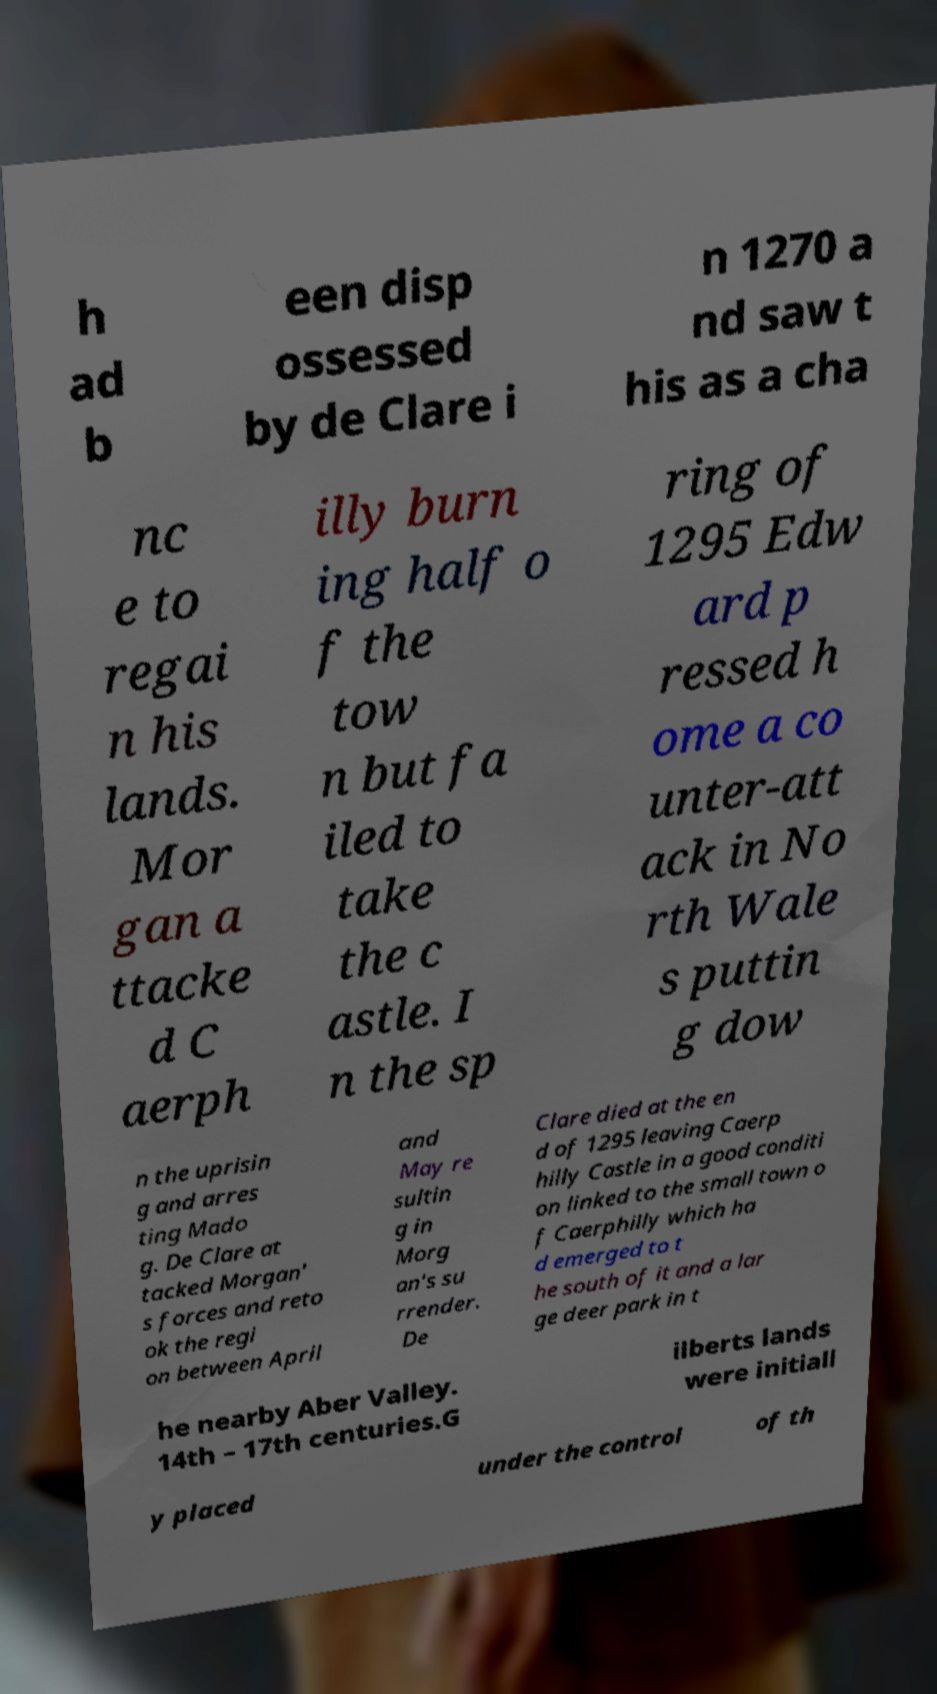Can you accurately transcribe the text from the provided image for me? h ad b een disp ossessed by de Clare i n 1270 a nd saw t his as a cha nc e to regai n his lands. Mor gan a ttacke d C aerph illy burn ing half o f the tow n but fa iled to take the c astle. I n the sp ring of 1295 Edw ard p ressed h ome a co unter-att ack in No rth Wale s puttin g dow n the uprisin g and arres ting Mado g. De Clare at tacked Morgan' s forces and reto ok the regi on between April and May re sultin g in Morg an's su rrender. De Clare died at the en d of 1295 leaving Caerp hilly Castle in a good conditi on linked to the small town o f Caerphilly which ha d emerged to t he south of it and a lar ge deer park in t he nearby Aber Valley. 14th – 17th centuries.G ilberts lands were initiall y placed under the control of th 